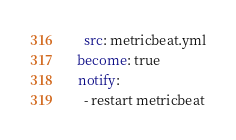Convert code to text. <code><loc_0><loc_0><loc_500><loc_500><_YAML_>    src: metricbeat.yml
  become: true
  notify:
    - restart metricbeat
</code> 